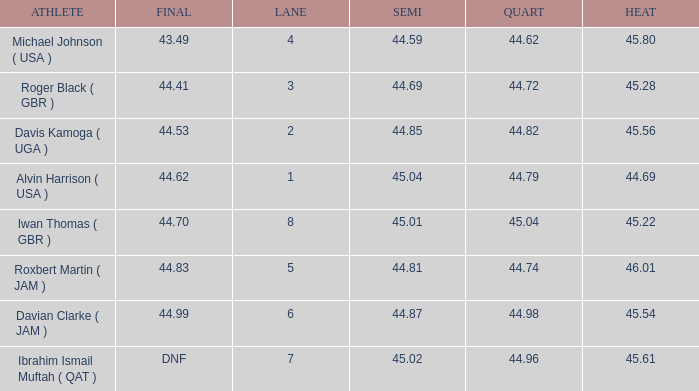When a lane of 4 has a QUART greater than 44.62, what is the lowest HEAT? None. 